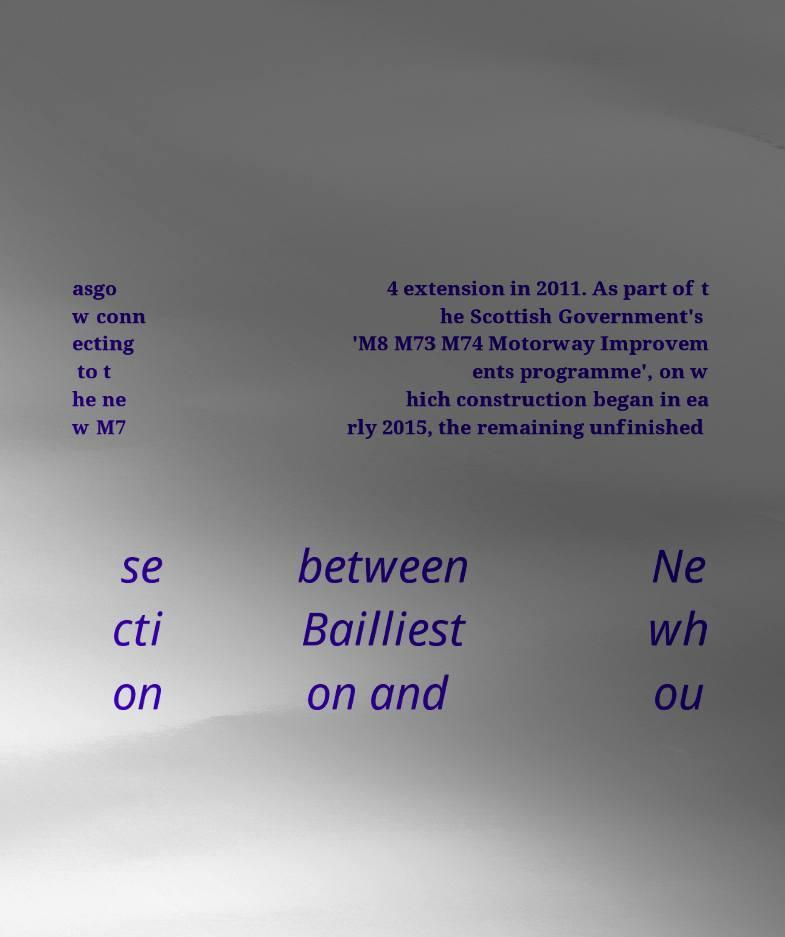What messages or text are displayed in this image? I need them in a readable, typed format. asgo w conn ecting to t he ne w M7 4 extension in 2011. As part of t he Scottish Government's 'M8 M73 M74 Motorway Improvem ents programme', on w hich construction began in ea rly 2015, the remaining unfinished se cti on between Bailliest on and Ne wh ou 